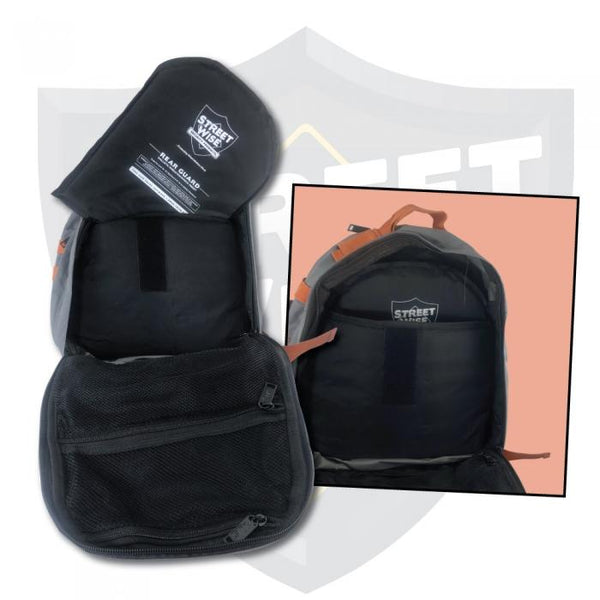What other activities besides cycling or motorcycling could this backpack be suitable for, and how might its features be beneficial in those contexts? Besides cycling and motorcycling, this backpack could be highly suitable for activities such as hiking, commuting, and traveling. The enhanced visibility features would be equally beneficial in hiking, allowing the wearer to be seen by others on trails, particularly during dawn or dusk. For commuters, the ability to store a helmet and other essentials in a well-ventilated and organized manner can be very practical. Travelers would appreciate the safety features and the capacity to separate wet or dirty clothes from clean items within the backpack, maintaining hygiene and convenience. 